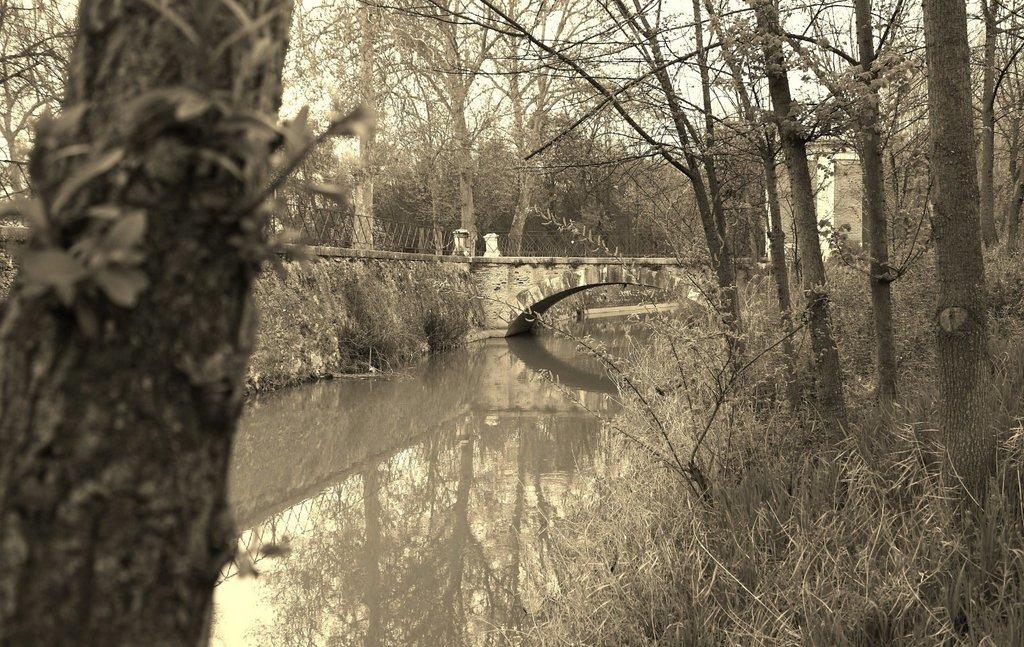Describe this image in one or two sentences. As we can see in the image there are trees, water and fence. On the right side there is a building. On the top there is a sky. 